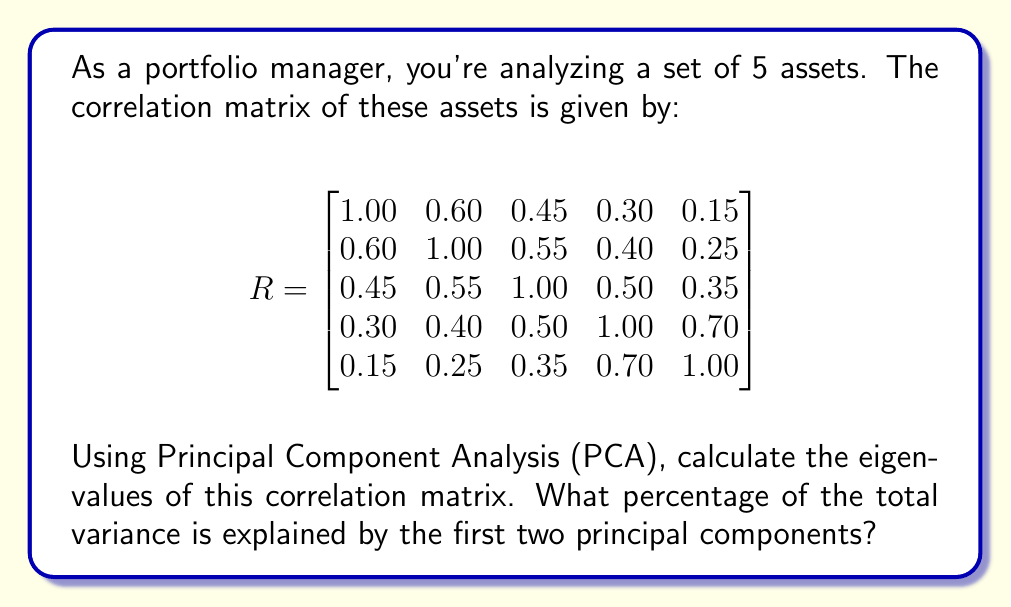Provide a solution to this math problem. To solve this problem, we'll follow these steps:

1) First, we need to calculate the eigenvalues of the correlation matrix. This can be done using a computer algebra system or numerical methods. The eigenvalues (λ) of the correlation matrix R are:

   $$\lambda_1 = 2.7416$$
   $$\lambda_2 = 1.0584$$
   $$\lambda_3 = 0.5868$$
   $$\lambda_4 = 0.3992$$
   $$\lambda_5 = 0.2140$$

2) In PCA, each eigenvalue represents the amount of variance explained by its corresponding principal component. The total variance is equal to the sum of all eigenvalues.

3) Calculate the total variance:

   $$\text{Total Variance} = \sum_{i=1}^5 \lambda_i = 2.7416 + 1.0584 + 0.5868 + 0.3992 + 0.2140 = 5$$

   Note that for a correlation matrix, the total variance is always equal to the number of variables (in this case, 5).

4) Calculate the proportion of variance explained by each principal component:

   $$\text{Proportion}_i = \frac{\lambda_i}{\text{Total Variance}}$$

5) For the first two principal components:

   $$\text{Proportion}_1 = \frac{2.7416}{5} = 0.5483 \text{ or } 54.83\%$$
   $$\text{Proportion}_2 = \frac{1.0584}{5} = 0.2117 \text{ or } 21.17\%$$

6) Sum these proportions to get the total variance explained by the first two principal components:

   $$\text{Total Proportion} = 0.5483 + 0.2117 = 0.7600 \text{ or } 76.00\%$$

Therefore, the first two principal components explain 76.00% of the total variance in the data.
Answer: 76.00% 